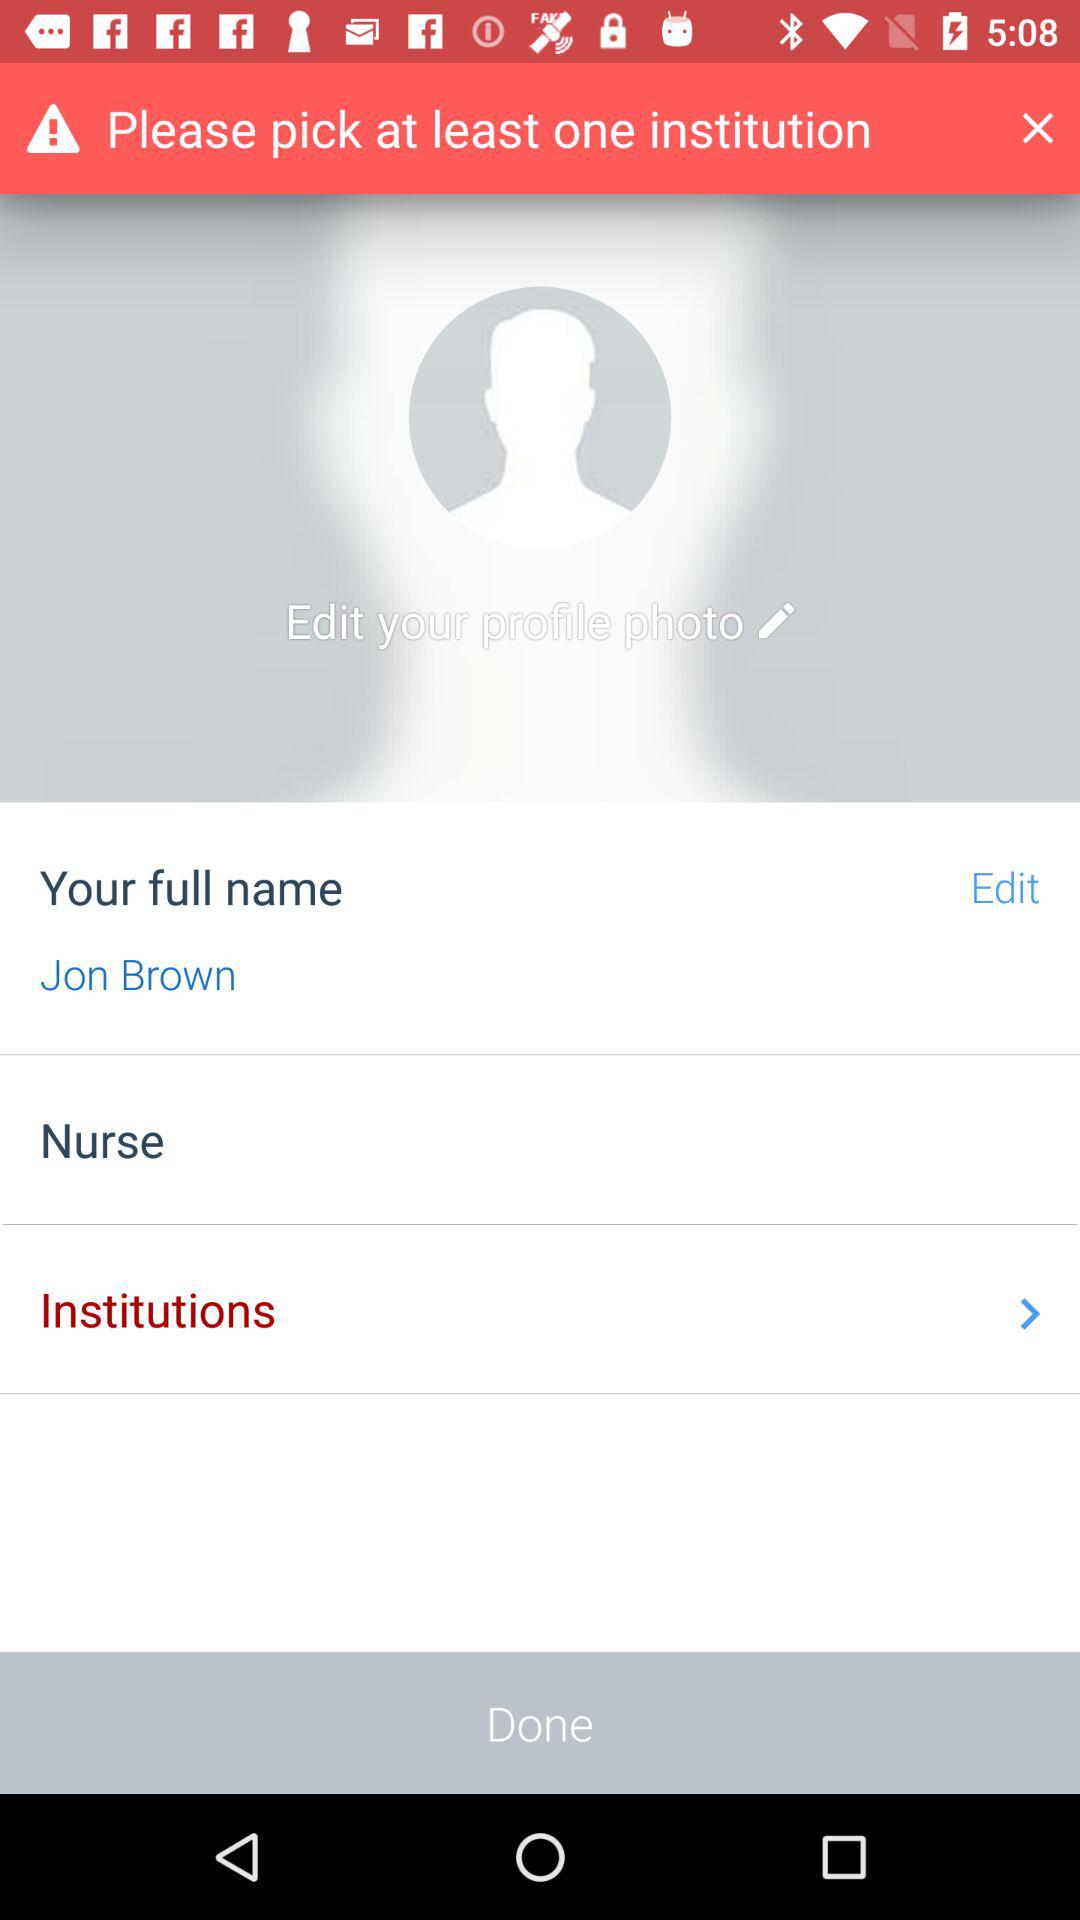How many more institutions do I need to pick?
Answer the question using a single word or phrase. 1 